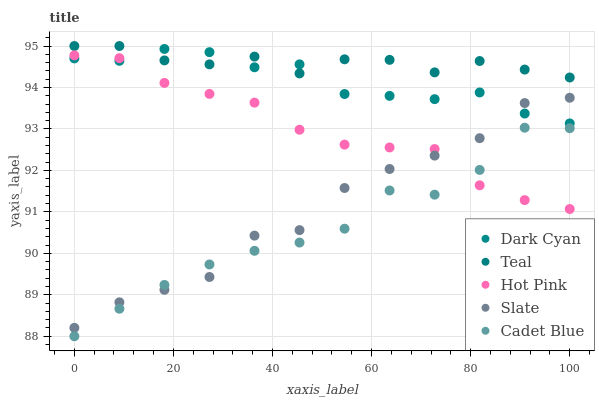Does Cadet Blue have the minimum area under the curve?
Answer yes or no. Yes. Does Teal have the maximum area under the curve?
Answer yes or no. Yes. Does Slate have the minimum area under the curve?
Answer yes or no. No. Does Slate have the maximum area under the curve?
Answer yes or no. No. Is Hot Pink the smoothest?
Answer yes or no. Yes. Is Slate the roughest?
Answer yes or no. Yes. Is Slate the smoothest?
Answer yes or no. No. Is Hot Pink the roughest?
Answer yes or no. No. Does Cadet Blue have the lowest value?
Answer yes or no. Yes. Does Slate have the lowest value?
Answer yes or no. No. Does Teal have the highest value?
Answer yes or no. Yes. Does Slate have the highest value?
Answer yes or no. No. Is Hot Pink less than Teal?
Answer yes or no. Yes. Is Teal greater than Slate?
Answer yes or no. Yes. Does Slate intersect Cadet Blue?
Answer yes or no. Yes. Is Slate less than Cadet Blue?
Answer yes or no. No. Is Slate greater than Cadet Blue?
Answer yes or no. No. Does Hot Pink intersect Teal?
Answer yes or no. No. 